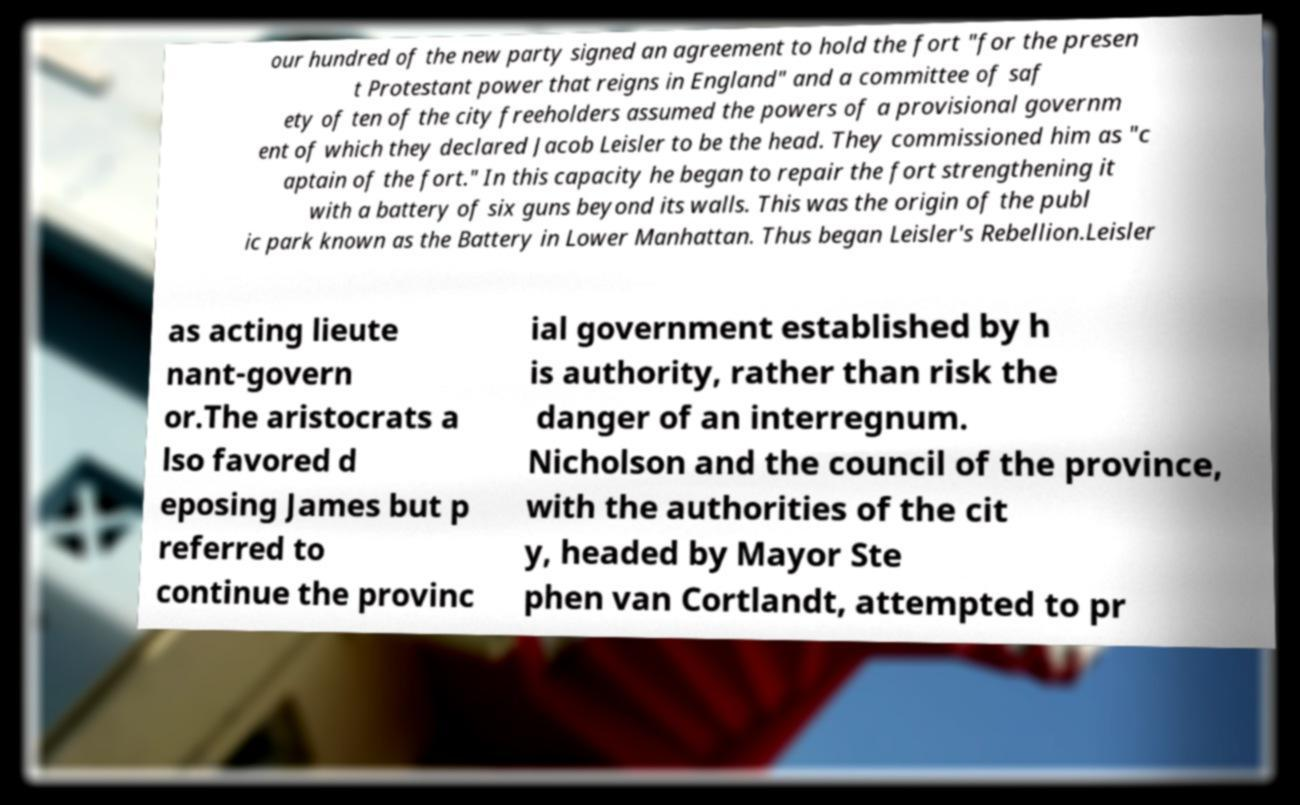Could you assist in decoding the text presented in this image and type it out clearly? our hundred of the new party signed an agreement to hold the fort "for the presen t Protestant power that reigns in England" and a committee of saf ety of ten of the city freeholders assumed the powers of a provisional governm ent of which they declared Jacob Leisler to be the head. They commissioned him as "c aptain of the fort." In this capacity he began to repair the fort strengthening it with a battery of six guns beyond its walls. This was the origin of the publ ic park known as the Battery in Lower Manhattan. Thus began Leisler's Rebellion.Leisler as acting lieute nant-govern or.The aristocrats a lso favored d eposing James but p referred to continue the provinc ial government established by h is authority, rather than risk the danger of an interregnum. Nicholson and the council of the province, with the authorities of the cit y, headed by Mayor Ste phen van Cortlandt, attempted to pr 